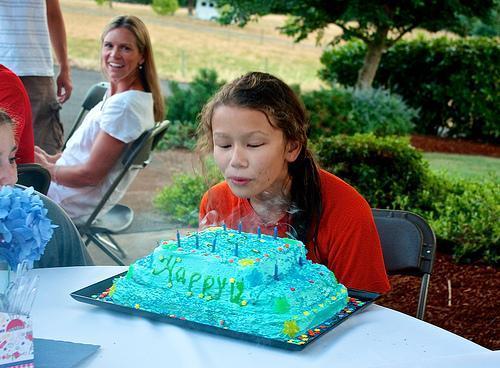How many years is this girl celebrating?
Give a very brief answer. 12. 